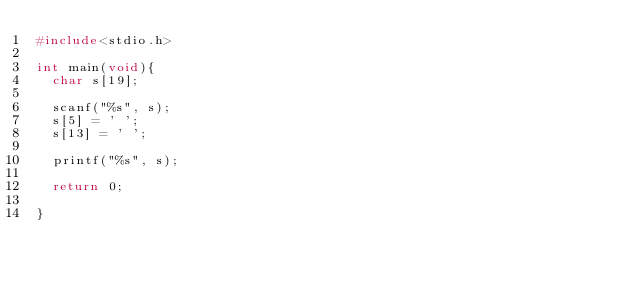Convert code to text. <code><loc_0><loc_0><loc_500><loc_500><_C_>#include<stdio.h>

int main(void){
  char s[19];

  scanf("%s", s);
  s[5] = ' ';
  s[13] = ' ';

  printf("%s", s);

  return 0;

}
</code> 